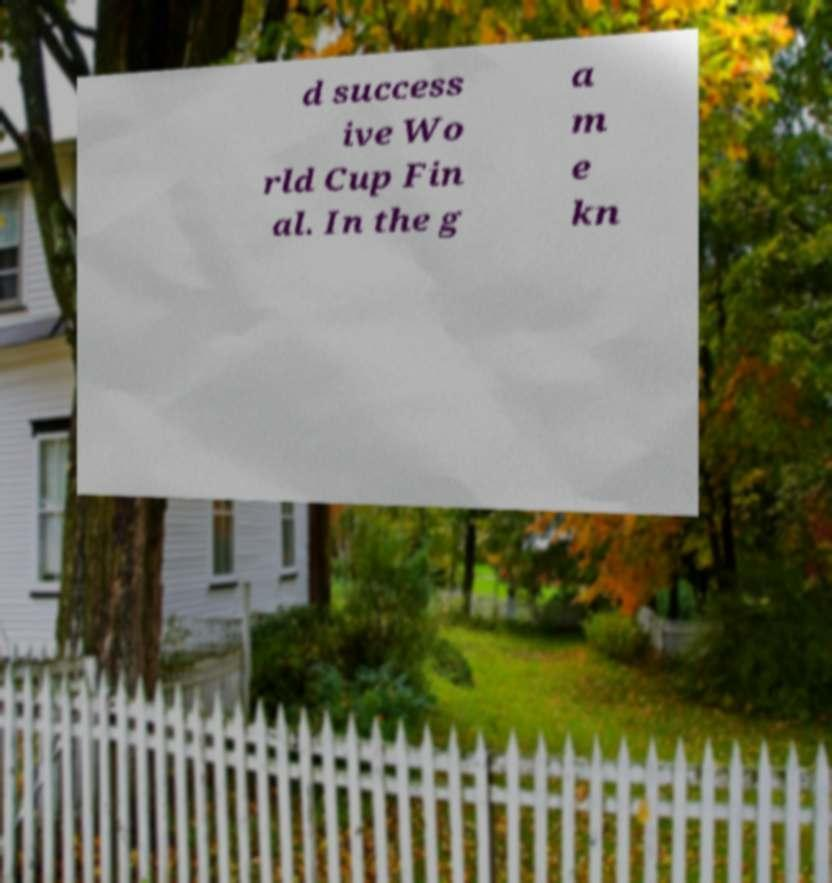Please identify and transcribe the text found in this image. d success ive Wo rld Cup Fin al. In the g a m e kn 